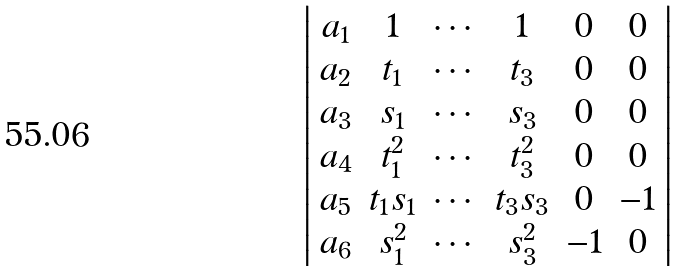<formula> <loc_0><loc_0><loc_500><loc_500>& \left | \begin{array} { c c c c c c } a _ { 1 } & 1 & \cdots & 1 & 0 & 0 \\ a _ { 2 } & t _ { 1 } & \cdots & t _ { 3 } & 0 & 0 \\ a _ { 3 } & s _ { 1 } & \cdots & s _ { 3 } & 0 & 0 \\ a _ { 4 } & t _ { 1 } ^ { 2 } & \cdots & t _ { 3 } ^ { 2 } & 0 & 0 \\ a _ { 5 } & t _ { 1 } s _ { 1 } & \cdots & t _ { 3 } s _ { 3 } & 0 & - 1 \\ a _ { 6 } & s _ { 1 } ^ { 2 } & \cdots & s _ { 3 } ^ { 2 } & - 1 & 0 \end{array} \right |</formula> 